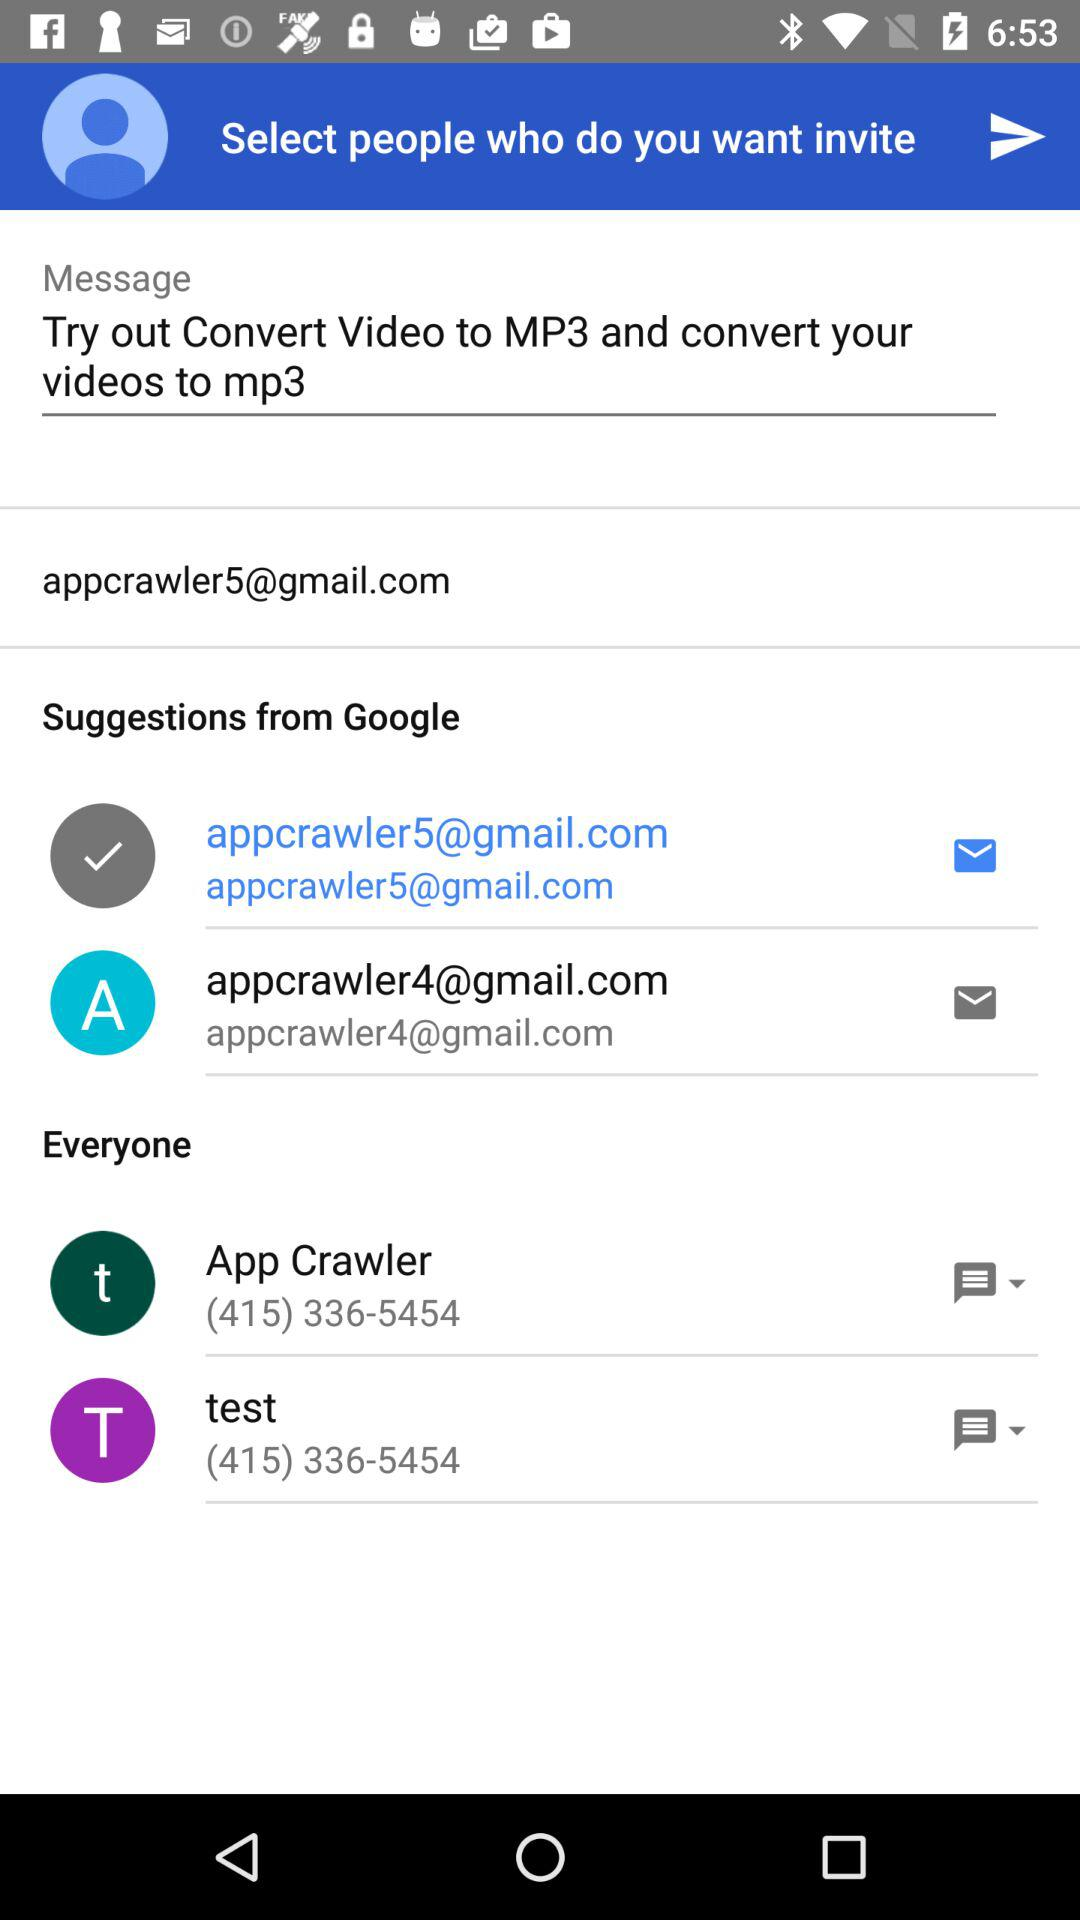How many people have not been selected?
Answer the question using a single word or phrase. 2 